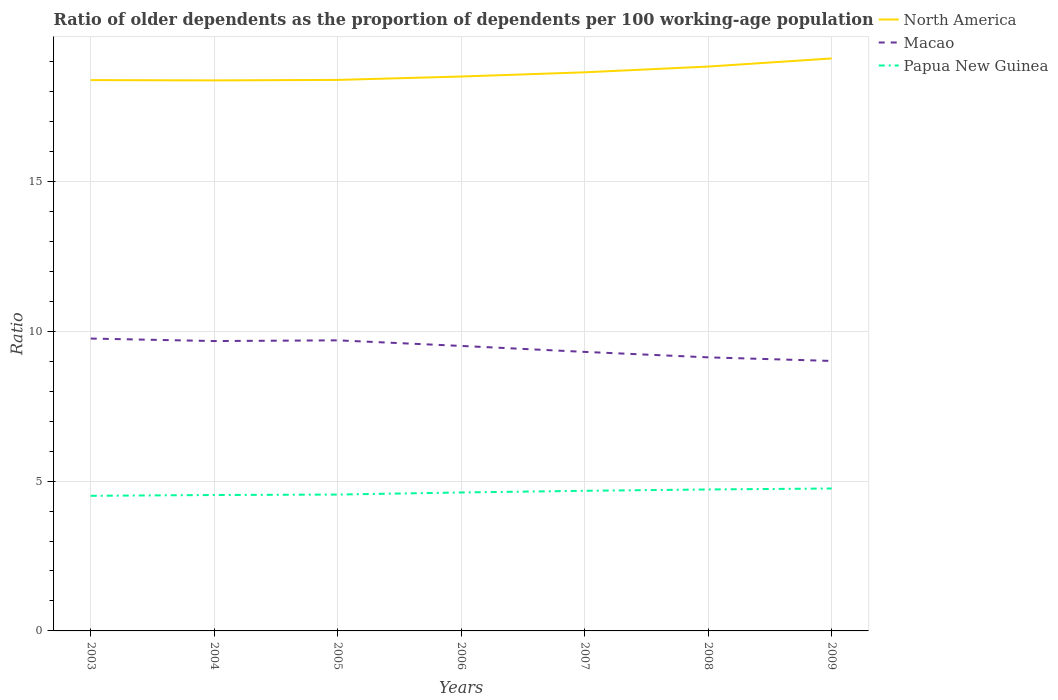Is the number of lines equal to the number of legend labels?
Your response must be concise. Yes. Across all years, what is the maximum age dependency ratio(old) in Macao?
Your response must be concise. 9.01. What is the total age dependency ratio(old) in North America in the graph?
Ensure brevity in your answer.  -0.27. What is the difference between the highest and the second highest age dependency ratio(old) in Macao?
Keep it short and to the point. 0.75. Is the age dependency ratio(old) in Papua New Guinea strictly greater than the age dependency ratio(old) in North America over the years?
Your response must be concise. Yes. How many years are there in the graph?
Ensure brevity in your answer.  7. What is the difference between two consecutive major ticks on the Y-axis?
Provide a short and direct response. 5. Are the values on the major ticks of Y-axis written in scientific E-notation?
Your answer should be very brief. No. How many legend labels are there?
Make the answer very short. 3. What is the title of the graph?
Your answer should be compact. Ratio of older dependents as the proportion of dependents per 100 working-age population. What is the label or title of the X-axis?
Your answer should be very brief. Years. What is the label or title of the Y-axis?
Provide a succinct answer. Ratio. What is the Ratio of North America in 2003?
Your response must be concise. 18.38. What is the Ratio in Macao in 2003?
Give a very brief answer. 9.75. What is the Ratio in Papua New Guinea in 2003?
Keep it short and to the point. 4.51. What is the Ratio in North America in 2004?
Ensure brevity in your answer.  18.37. What is the Ratio in Macao in 2004?
Your answer should be very brief. 9.67. What is the Ratio in Papua New Guinea in 2004?
Offer a very short reply. 4.53. What is the Ratio in North America in 2005?
Give a very brief answer. 18.38. What is the Ratio in Macao in 2005?
Make the answer very short. 9.69. What is the Ratio of Papua New Guinea in 2005?
Ensure brevity in your answer.  4.55. What is the Ratio in North America in 2006?
Provide a succinct answer. 18.5. What is the Ratio in Macao in 2006?
Provide a succinct answer. 9.51. What is the Ratio of Papua New Guinea in 2006?
Offer a very short reply. 4.62. What is the Ratio in North America in 2007?
Your answer should be compact. 18.64. What is the Ratio of Macao in 2007?
Make the answer very short. 9.31. What is the Ratio in Papua New Guinea in 2007?
Your answer should be very brief. 4.68. What is the Ratio in North America in 2008?
Keep it short and to the point. 18.83. What is the Ratio in Macao in 2008?
Give a very brief answer. 9.13. What is the Ratio of Papua New Guinea in 2008?
Make the answer very short. 4.72. What is the Ratio of North America in 2009?
Offer a very short reply. 19.1. What is the Ratio in Macao in 2009?
Ensure brevity in your answer.  9.01. What is the Ratio of Papua New Guinea in 2009?
Make the answer very short. 4.75. Across all years, what is the maximum Ratio in North America?
Provide a short and direct response. 19.1. Across all years, what is the maximum Ratio in Macao?
Ensure brevity in your answer.  9.75. Across all years, what is the maximum Ratio of Papua New Guinea?
Offer a terse response. 4.75. Across all years, what is the minimum Ratio of North America?
Ensure brevity in your answer.  18.37. Across all years, what is the minimum Ratio in Macao?
Provide a succinct answer. 9.01. Across all years, what is the minimum Ratio of Papua New Guinea?
Your answer should be very brief. 4.51. What is the total Ratio in North America in the graph?
Offer a terse response. 130.19. What is the total Ratio in Macao in the graph?
Make the answer very short. 66.07. What is the total Ratio of Papua New Guinea in the graph?
Offer a terse response. 32.36. What is the difference between the Ratio in North America in 2003 and that in 2004?
Offer a terse response. 0.01. What is the difference between the Ratio in Macao in 2003 and that in 2004?
Give a very brief answer. 0.08. What is the difference between the Ratio of Papua New Guinea in 2003 and that in 2004?
Provide a short and direct response. -0.03. What is the difference between the Ratio of North America in 2003 and that in 2005?
Offer a very short reply. -0.01. What is the difference between the Ratio in Macao in 2003 and that in 2005?
Provide a short and direct response. 0.06. What is the difference between the Ratio in Papua New Guinea in 2003 and that in 2005?
Your answer should be compact. -0.04. What is the difference between the Ratio of North America in 2003 and that in 2006?
Offer a terse response. -0.12. What is the difference between the Ratio in Macao in 2003 and that in 2006?
Give a very brief answer. 0.25. What is the difference between the Ratio of Papua New Guinea in 2003 and that in 2006?
Provide a short and direct response. -0.11. What is the difference between the Ratio in North America in 2003 and that in 2007?
Offer a very short reply. -0.26. What is the difference between the Ratio in Macao in 2003 and that in 2007?
Provide a short and direct response. 0.44. What is the difference between the Ratio of Papua New Guinea in 2003 and that in 2007?
Your response must be concise. -0.17. What is the difference between the Ratio in North America in 2003 and that in 2008?
Provide a short and direct response. -0.45. What is the difference between the Ratio in Macao in 2003 and that in 2008?
Your answer should be very brief. 0.63. What is the difference between the Ratio in Papua New Guinea in 2003 and that in 2008?
Offer a very short reply. -0.21. What is the difference between the Ratio of North America in 2003 and that in 2009?
Make the answer very short. -0.72. What is the difference between the Ratio in Macao in 2003 and that in 2009?
Offer a terse response. 0.75. What is the difference between the Ratio of Papua New Guinea in 2003 and that in 2009?
Provide a succinct answer. -0.24. What is the difference between the Ratio in North America in 2004 and that in 2005?
Keep it short and to the point. -0.02. What is the difference between the Ratio in Macao in 2004 and that in 2005?
Provide a short and direct response. -0.02. What is the difference between the Ratio of Papua New Guinea in 2004 and that in 2005?
Your response must be concise. -0.02. What is the difference between the Ratio of North America in 2004 and that in 2006?
Give a very brief answer. -0.13. What is the difference between the Ratio in Macao in 2004 and that in 2006?
Make the answer very short. 0.16. What is the difference between the Ratio of Papua New Guinea in 2004 and that in 2006?
Your answer should be very brief. -0.08. What is the difference between the Ratio in North America in 2004 and that in 2007?
Your answer should be very brief. -0.27. What is the difference between the Ratio in Macao in 2004 and that in 2007?
Ensure brevity in your answer.  0.36. What is the difference between the Ratio of Papua New Guinea in 2004 and that in 2007?
Offer a very short reply. -0.14. What is the difference between the Ratio in North America in 2004 and that in 2008?
Offer a very short reply. -0.46. What is the difference between the Ratio of Macao in 2004 and that in 2008?
Make the answer very short. 0.54. What is the difference between the Ratio of Papua New Guinea in 2004 and that in 2008?
Offer a terse response. -0.19. What is the difference between the Ratio of North America in 2004 and that in 2009?
Your answer should be compact. -0.73. What is the difference between the Ratio of Macao in 2004 and that in 2009?
Offer a very short reply. 0.66. What is the difference between the Ratio of Papua New Guinea in 2004 and that in 2009?
Offer a very short reply. -0.22. What is the difference between the Ratio of North America in 2005 and that in 2006?
Keep it short and to the point. -0.11. What is the difference between the Ratio of Macao in 2005 and that in 2006?
Provide a short and direct response. 0.19. What is the difference between the Ratio in Papua New Guinea in 2005 and that in 2006?
Your response must be concise. -0.07. What is the difference between the Ratio in North America in 2005 and that in 2007?
Your response must be concise. -0.25. What is the difference between the Ratio in Macao in 2005 and that in 2007?
Your answer should be compact. 0.39. What is the difference between the Ratio in Papua New Guinea in 2005 and that in 2007?
Keep it short and to the point. -0.13. What is the difference between the Ratio of North America in 2005 and that in 2008?
Provide a succinct answer. -0.45. What is the difference between the Ratio in Macao in 2005 and that in 2008?
Provide a succinct answer. 0.57. What is the difference between the Ratio in Papua New Guinea in 2005 and that in 2008?
Give a very brief answer. -0.17. What is the difference between the Ratio in North America in 2005 and that in 2009?
Your response must be concise. -0.72. What is the difference between the Ratio in Macao in 2005 and that in 2009?
Your answer should be compact. 0.69. What is the difference between the Ratio in Papua New Guinea in 2005 and that in 2009?
Provide a succinct answer. -0.2. What is the difference between the Ratio in North America in 2006 and that in 2007?
Offer a terse response. -0.14. What is the difference between the Ratio in Macao in 2006 and that in 2007?
Provide a succinct answer. 0.2. What is the difference between the Ratio in Papua New Guinea in 2006 and that in 2007?
Ensure brevity in your answer.  -0.06. What is the difference between the Ratio in North America in 2006 and that in 2008?
Provide a succinct answer. -0.33. What is the difference between the Ratio in Macao in 2006 and that in 2008?
Provide a succinct answer. 0.38. What is the difference between the Ratio in Papua New Guinea in 2006 and that in 2008?
Make the answer very short. -0.1. What is the difference between the Ratio in North America in 2006 and that in 2009?
Offer a very short reply. -0.6. What is the difference between the Ratio of Macao in 2006 and that in 2009?
Make the answer very short. 0.5. What is the difference between the Ratio of Papua New Guinea in 2006 and that in 2009?
Provide a short and direct response. -0.13. What is the difference between the Ratio of North America in 2007 and that in 2008?
Make the answer very short. -0.19. What is the difference between the Ratio of Macao in 2007 and that in 2008?
Your answer should be very brief. 0.18. What is the difference between the Ratio in Papua New Guinea in 2007 and that in 2008?
Your answer should be compact. -0.04. What is the difference between the Ratio of North America in 2007 and that in 2009?
Provide a succinct answer. -0.46. What is the difference between the Ratio of Macao in 2007 and that in 2009?
Offer a very short reply. 0.3. What is the difference between the Ratio in Papua New Guinea in 2007 and that in 2009?
Make the answer very short. -0.08. What is the difference between the Ratio in North America in 2008 and that in 2009?
Offer a very short reply. -0.27. What is the difference between the Ratio of Macao in 2008 and that in 2009?
Your response must be concise. 0.12. What is the difference between the Ratio of Papua New Guinea in 2008 and that in 2009?
Offer a very short reply. -0.03. What is the difference between the Ratio in North America in 2003 and the Ratio in Macao in 2004?
Your answer should be very brief. 8.71. What is the difference between the Ratio in North America in 2003 and the Ratio in Papua New Guinea in 2004?
Your answer should be compact. 13.84. What is the difference between the Ratio of Macao in 2003 and the Ratio of Papua New Guinea in 2004?
Make the answer very short. 5.22. What is the difference between the Ratio of North America in 2003 and the Ratio of Macao in 2005?
Provide a short and direct response. 8.68. What is the difference between the Ratio in North America in 2003 and the Ratio in Papua New Guinea in 2005?
Keep it short and to the point. 13.83. What is the difference between the Ratio in Macao in 2003 and the Ratio in Papua New Guinea in 2005?
Your response must be concise. 5.2. What is the difference between the Ratio of North America in 2003 and the Ratio of Macao in 2006?
Give a very brief answer. 8.87. What is the difference between the Ratio of North America in 2003 and the Ratio of Papua New Guinea in 2006?
Provide a short and direct response. 13.76. What is the difference between the Ratio in Macao in 2003 and the Ratio in Papua New Guinea in 2006?
Your response must be concise. 5.14. What is the difference between the Ratio of North America in 2003 and the Ratio of Macao in 2007?
Keep it short and to the point. 9.07. What is the difference between the Ratio of North America in 2003 and the Ratio of Papua New Guinea in 2007?
Your response must be concise. 13.7. What is the difference between the Ratio in Macao in 2003 and the Ratio in Papua New Guinea in 2007?
Provide a short and direct response. 5.08. What is the difference between the Ratio of North America in 2003 and the Ratio of Macao in 2008?
Your answer should be compact. 9.25. What is the difference between the Ratio in North America in 2003 and the Ratio in Papua New Guinea in 2008?
Ensure brevity in your answer.  13.66. What is the difference between the Ratio in Macao in 2003 and the Ratio in Papua New Guinea in 2008?
Your answer should be very brief. 5.03. What is the difference between the Ratio in North America in 2003 and the Ratio in Macao in 2009?
Keep it short and to the point. 9.37. What is the difference between the Ratio of North America in 2003 and the Ratio of Papua New Guinea in 2009?
Your response must be concise. 13.62. What is the difference between the Ratio in Macao in 2003 and the Ratio in Papua New Guinea in 2009?
Give a very brief answer. 5. What is the difference between the Ratio in North America in 2004 and the Ratio in Macao in 2005?
Your answer should be compact. 8.67. What is the difference between the Ratio of North America in 2004 and the Ratio of Papua New Guinea in 2005?
Make the answer very short. 13.82. What is the difference between the Ratio in Macao in 2004 and the Ratio in Papua New Guinea in 2005?
Keep it short and to the point. 5.12. What is the difference between the Ratio of North America in 2004 and the Ratio of Macao in 2006?
Your answer should be very brief. 8.86. What is the difference between the Ratio of North America in 2004 and the Ratio of Papua New Guinea in 2006?
Your answer should be very brief. 13.75. What is the difference between the Ratio of Macao in 2004 and the Ratio of Papua New Guinea in 2006?
Ensure brevity in your answer.  5.05. What is the difference between the Ratio of North America in 2004 and the Ratio of Macao in 2007?
Offer a terse response. 9.06. What is the difference between the Ratio of North America in 2004 and the Ratio of Papua New Guinea in 2007?
Your answer should be compact. 13.69. What is the difference between the Ratio in Macao in 2004 and the Ratio in Papua New Guinea in 2007?
Offer a very short reply. 5. What is the difference between the Ratio in North America in 2004 and the Ratio in Macao in 2008?
Give a very brief answer. 9.24. What is the difference between the Ratio of North America in 2004 and the Ratio of Papua New Guinea in 2008?
Your answer should be compact. 13.65. What is the difference between the Ratio in Macao in 2004 and the Ratio in Papua New Guinea in 2008?
Make the answer very short. 4.95. What is the difference between the Ratio of North America in 2004 and the Ratio of Macao in 2009?
Your answer should be compact. 9.36. What is the difference between the Ratio of North America in 2004 and the Ratio of Papua New Guinea in 2009?
Your response must be concise. 13.62. What is the difference between the Ratio of Macao in 2004 and the Ratio of Papua New Guinea in 2009?
Offer a very short reply. 4.92. What is the difference between the Ratio of North America in 2005 and the Ratio of Macao in 2006?
Provide a succinct answer. 8.88. What is the difference between the Ratio in North America in 2005 and the Ratio in Papua New Guinea in 2006?
Your response must be concise. 13.76. What is the difference between the Ratio in Macao in 2005 and the Ratio in Papua New Guinea in 2006?
Offer a very short reply. 5.08. What is the difference between the Ratio in North America in 2005 and the Ratio in Macao in 2007?
Keep it short and to the point. 9.07. What is the difference between the Ratio in North America in 2005 and the Ratio in Papua New Guinea in 2007?
Give a very brief answer. 13.71. What is the difference between the Ratio of Macao in 2005 and the Ratio of Papua New Guinea in 2007?
Ensure brevity in your answer.  5.02. What is the difference between the Ratio of North America in 2005 and the Ratio of Macao in 2008?
Your answer should be compact. 9.26. What is the difference between the Ratio in North America in 2005 and the Ratio in Papua New Guinea in 2008?
Make the answer very short. 13.66. What is the difference between the Ratio in Macao in 2005 and the Ratio in Papua New Guinea in 2008?
Offer a terse response. 4.98. What is the difference between the Ratio in North America in 2005 and the Ratio in Macao in 2009?
Your answer should be very brief. 9.38. What is the difference between the Ratio in North America in 2005 and the Ratio in Papua New Guinea in 2009?
Offer a terse response. 13.63. What is the difference between the Ratio of Macao in 2005 and the Ratio of Papua New Guinea in 2009?
Provide a succinct answer. 4.94. What is the difference between the Ratio in North America in 2006 and the Ratio in Macao in 2007?
Offer a very short reply. 9.19. What is the difference between the Ratio of North America in 2006 and the Ratio of Papua New Guinea in 2007?
Your response must be concise. 13.82. What is the difference between the Ratio of Macao in 2006 and the Ratio of Papua New Guinea in 2007?
Provide a short and direct response. 4.83. What is the difference between the Ratio in North America in 2006 and the Ratio in Macao in 2008?
Give a very brief answer. 9.37. What is the difference between the Ratio in North America in 2006 and the Ratio in Papua New Guinea in 2008?
Offer a very short reply. 13.78. What is the difference between the Ratio of Macao in 2006 and the Ratio of Papua New Guinea in 2008?
Your response must be concise. 4.79. What is the difference between the Ratio of North America in 2006 and the Ratio of Macao in 2009?
Your answer should be very brief. 9.49. What is the difference between the Ratio in North America in 2006 and the Ratio in Papua New Guinea in 2009?
Offer a terse response. 13.74. What is the difference between the Ratio in Macao in 2006 and the Ratio in Papua New Guinea in 2009?
Keep it short and to the point. 4.76. What is the difference between the Ratio in North America in 2007 and the Ratio in Macao in 2008?
Give a very brief answer. 9.51. What is the difference between the Ratio of North America in 2007 and the Ratio of Papua New Guinea in 2008?
Your response must be concise. 13.92. What is the difference between the Ratio in Macao in 2007 and the Ratio in Papua New Guinea in 2008?
Ensure brevity in your answer.  4.59. What is the difference between the Ratio of North America in 2007 and the Ratio of Macao in 2009?
Your response must be concise. 9.63. What is the difference between the Ratio in North America in 2007 and the Ratio in Papua New Guinea in 2009?
Your response must be concise. 13.88. What is the difference between the Ratio in Macao in 2007 and the Ratio in Papua New Guinea in 2009?
Make the answer very short. 4.56. What is the difference between the Ratio in North America in 2008 and the Ratio in Macao in 2009?
Provide a succinct answer. 9.82. What is the difference between the Ratio in North America in 2008 and the Ratio in Papua New Guinea in 2009?
Your response must be concise. 14.08. What is the difference between the Ratio of Macao in 2008 and the Ratio of Papua New Guinea in 2009?
Provide a short and direct response. 4.38. What is the average Ratio in North America per year?
Your answer should be very brief. 18.6. What is the average Ratio of Macao per year?
Offer a very short reply. 9.44. What is the average Ratio in Papua New Guinea per year?
Offer a very short reply. 4.62. In the year 2003, what is the difference between the Ratio of North America and Ratio of Macao?
Keep it short and to the point. 8.62. In the year 2003, what is the difference between the Ratio in North America and Ratio in Papua New Guinea?
Ensure brevity in your answer.  13.87. In the year 2003, what is the difference between the Ratio in Macao and Ratio in Papua New Guinea?
Give a very brief answer. 5.25. In the year 2004, what is the difference between the Ratio of North America and Ratio of Macao?
Offer a very short reply. 8.7. In the year 2004, what is the difference between the Ratio in North America and Ratio in Papua New Guinea?
Keep it short and to the point. 13.83. In the year 2004, what is the difference between the Ratio in Macao and Ratio in Papua New Guinea?
Ensure brevity in your answer.  5.14. In the year 2005, what is the difference between the Ratio of North America and Ratio of Macao?
Provide a succinct answer. 8.69. In the year 2005, what is the difference between the Ratio of North America and Ratio of Papua New Guinea?
Provide a short and direct response. 13.83. In the year 2005, what is the difference between the Ratio in Macao and Ratio in Papua New Guinea?
Offer a very short reply. 5.14. In the year 2006, what is the difference between the Ratio of North America and Ratio of Macao?
Your response must be concise. 8.99. In the year 2006, what is the difference between the Ratio of North America and Ratio of Papua New Guinea?
Ensure brevity in your answer.  13.88. In the year 2006, what is the difference between the Ratio in Macao and Ratio in Papua New Guinea?
Offer a terse response. 4.89. In the year 2007, what is the difference between the Ratio of North America and Ratio of Macao?
Your answer should be compact. 9.33. In the year 2007, what is the difference between the Ratio of North America and Ratio of Papua New Guinea?
Provide a succinct answer. 13.96. In the year 2007, what is the difference between the Ratio of Macao and Ratio of Papua New Guinea?
Offer a terse response. 4.63. In the year 2008, what is the difference between the Ratio of North America and Ratio of Macao?
Keep it short and to the point. 9.7. In the year 2008, what is the difference between the Ratio of North America and Ratio of Papua New Guinea?
Provide a short and direct response. 14.11. In the year 2008, what is the difference between the Ratio in Macao and Ratio in Papua New Guinea?
Offer a very short reply. 4.41. In the year 2009, what is the difference between the Ratio of North America and Ratio of Macao?
Offer a very short reply. 10.09. In the year 2009, what is the difference between the Ratio in North America and Ratio in Papua New Guinea?
Keep it short and to the point. 14.35. In the year 2009, what is the difference between the Ratio of Macao and Ratio of Papua New Guinea?
Provide a short and direct response. 4.26. What is the ratio of the Ratio in North America in 2003 to that in 2004?
Your response must be concise. 1. What is the ratio of the Ratio in Macao in 2003 to that in 2004?
Provide a short and direct response. 1.01. What is the ratio of the Ratio of Papua New Guinea in 2003 to that in 2004?
Provide a short and direct response. 0.99. What is the ratio of the Ratio of North America in 2003 to that in 2005?
Keep it short and to the point. 1. What is the ratio of the Ratio in Macao in 2003 to that in 2005?
Offer a terse response. 1.01. What is the ratio of the Ratio in Papua New Guinea in 2003 to that in 2005?
Your response must be concise. 0.99. What is the ratio of the Ratio in North America in 2003 to that in 2006?
Your answer should be compact. 0.99. What is the ratio of the Ratio of Macao in 2003 to that in 2006?
Give a very brief answer. 1.03. What is the ratio of the Ratio of Papua New Guinea in 2003 to that in 2006?
Your response must be concise. 0.98. What is the ratio of the Ratio of North America in 2003 to that in 2007?
Provide a short and direct response. 0.99. What is the ratio of the Ratio in Macao in 2003 to that in 2007?
Your answer should be compact. 1.05. What is the ratio of the Ratio of Papua New Guinea in 2003 to that in 2007?
Your response must be concise. 0.96. What is the ratio of the Ratio of Macao in 2003 to that in 2008?
Give a very brief answer. 1.07. What is the ratio of the Ratio in Papua New Guinea in 2003 to that in 2008?
Ensure brevity in your answer.  0.96. What is the ratio of the Ratio in North America in 2003 to that in 2009?
Ensure brevity in your answer.  0.96. What is the ratio of the Ratio in Macao in 2003 to that in 2009?
Offer a very short reply. 1.08. What is the ratio of the Ratio of Papua New Guinea in 2003 to that in 2009?
Your answer should be compact. 0.95. What is the ratio of the Ratio of Macao in 2004 to that in 2006?
Give a very brief answer. 1.02. What is the ratio of the Ratio of Papua New Guinea in 2004 to that in 2006?
Make the answer very short. 0.98. What is the ratio of the Ratio of North America in 2004 to that in 2007?
Provide a short and direct response. 0.99. What is the ratio of the Ratio of Macao in 2004 to that in 2007?
Provide a short and direct response. 1.04. What is the ratio of the Ratio of Papua New Guinea in 2004 to that in 2007?
Give a very brief answer. 0.97. What is the ratio of the Ratio in North America in 2004 to that in 2008?
Offer a very short reply. 0.98. What is the ratio of the Ratio of Macao in 2004 to that in 2008?
Your response must be concise. 1.06. What is the ratio of the Ratio in Papua New Guinea in 2004 to that in 2008?
Ensure brevity in your answer.  0.96. What is the ratio of the Ratio in North America in 2004 to that in 2009?
Give a very brief answer. 0.96. What is the ratio of the Ratio of Macao in 2004 to that in 2009?
Ensure brevity in your answer.  1.07. What is the ratio of the Ratio in Papua New Guinea in 2004 to that in 2009?
Your answer should be very brief. 0.95. What is the ratio of the Ratio of North America in 2005 to that in 2006?
Your answer should be very brief. 0.99. What is the ratio of the Ratio of Macao in 2005 to that in 2006?
Make the answer very short. 1.02. What is the ratio of the Ratio in North America in 2005 to that in 2007?
Keep it short and to the point. 0.99. What is the ratio of the Ratio in Macao in 2005 to that in 2007?
Offer a terse response. 1.04. What is the ratio of the Ratio in Papua New Guinea in 2005 to that in 2007?
Offer a terse response. 0.97. What is the ratio of the Ratio of North America in 2005 to that in 2008?
Give a very brief answer. 0.98. What is the ratio of the Ratio in Macao in 2005 to that in 2008?
Ensure brevity in your answer.  1.06. What is the ratio of the Ratio of Papua New Guinea in 2005 to that in 2008?
Give a very brief answer. 0.96. What is the ratio of the Ratio in North America in 2005 to that in 2009?
Your answer should be very brief. 0.96. What is the ratio of the Ratio in Macao in 2005 to that in 2009?
Give a very brief answer. 1.08. What is the ratio of the Ratio in Papua New Guinea in 2005 to that in 2009?
Provide a succinct answer. 0.96. What is the ratio of the Ratio of North America in 2006 to that in 2007?
Provide a succinct answer. 0.99. What is the ratio of the Ratio in Macao in 2006 to that in 2007?
Offer a very short reply. 1.02. What is the ratio of the Ratio in Papua New Guinea in 2006 to that in 2007?
Make the answer very short. 0.99. What is the ratio of the Ratio in North America in 2006 to that in 2008?
Your answer should be very brief. 0.98. What is the ratio of the Ratio of Macao in 2006 to that in 2008?
Your answer should be very brief. 1.04. What is the ratio of the Ratio of Papua New Guinea in 2006 to that in 2008?
Provide a short and direct response. 0.98. What is the ratio of the Ratio in North America in 2006 to that in 2009?
Your answer should be very brief. 0.97. What is the ratio of the Ratio of Macao in 2006 to that in 2009?
Provide a short and direct response. 1.06. What is the ratio of the Ratio in North America in 2007 to that in 2008?
Your answer should be compact. 0.99. What is the ratio of the Ratio of Macao in 2007 to that in 2008?
Make the answer very short. 1.02. What is the ratio of the Ratio in Papua New Guinea in 2007 to that in 2008?
Keep it short and to the point. 0.99. What is the ratio of the Ratio in North America in 2007 to that in 2009?
Your answer should be very brief. 0.98. What is the ratio of the Ratio of Macao in 2007 to that in 2009?
Offer a very short reply. 1.03. What is the ratio of the Ratio in Papua New Guinea in 2007 to that in 2009?
Give a very brief answer. 0.98. What is the ratio of the Ratio of North America in 2008 to that in 2009?
Make the answer very short. 0.99. What is the ratio of the Ratio in Macao in 2008 to that in 2009?
Keep it short and to the point. 1.01. What is the ratio of the Ratio in Papua New Guinea in 2008 to that in 2009?
Your response must be concise. 0.99. What is the difference between the highest and the second highest Ratio of North America?
Provide a succinct answer. 0.27. What is the difference between the highest and the second highest Ratio of Macao?
Keep it short and to the point. 0.06. What is the difference between the highest and the second highest Ratio in Papua New Guinea?
Offer a very short reply. 0.03. What is the difference between the highest and the lowest Ratio of North America?
Your answer should be very brief. 0.73. What is the difference between the highest and the lowest Ratio of Macao?
Offer a terse response. 0.75. What is the difference between the highest and the lowest Ratio in Papua New Guinea?
Ensure brevity in your answer.  0.24. 